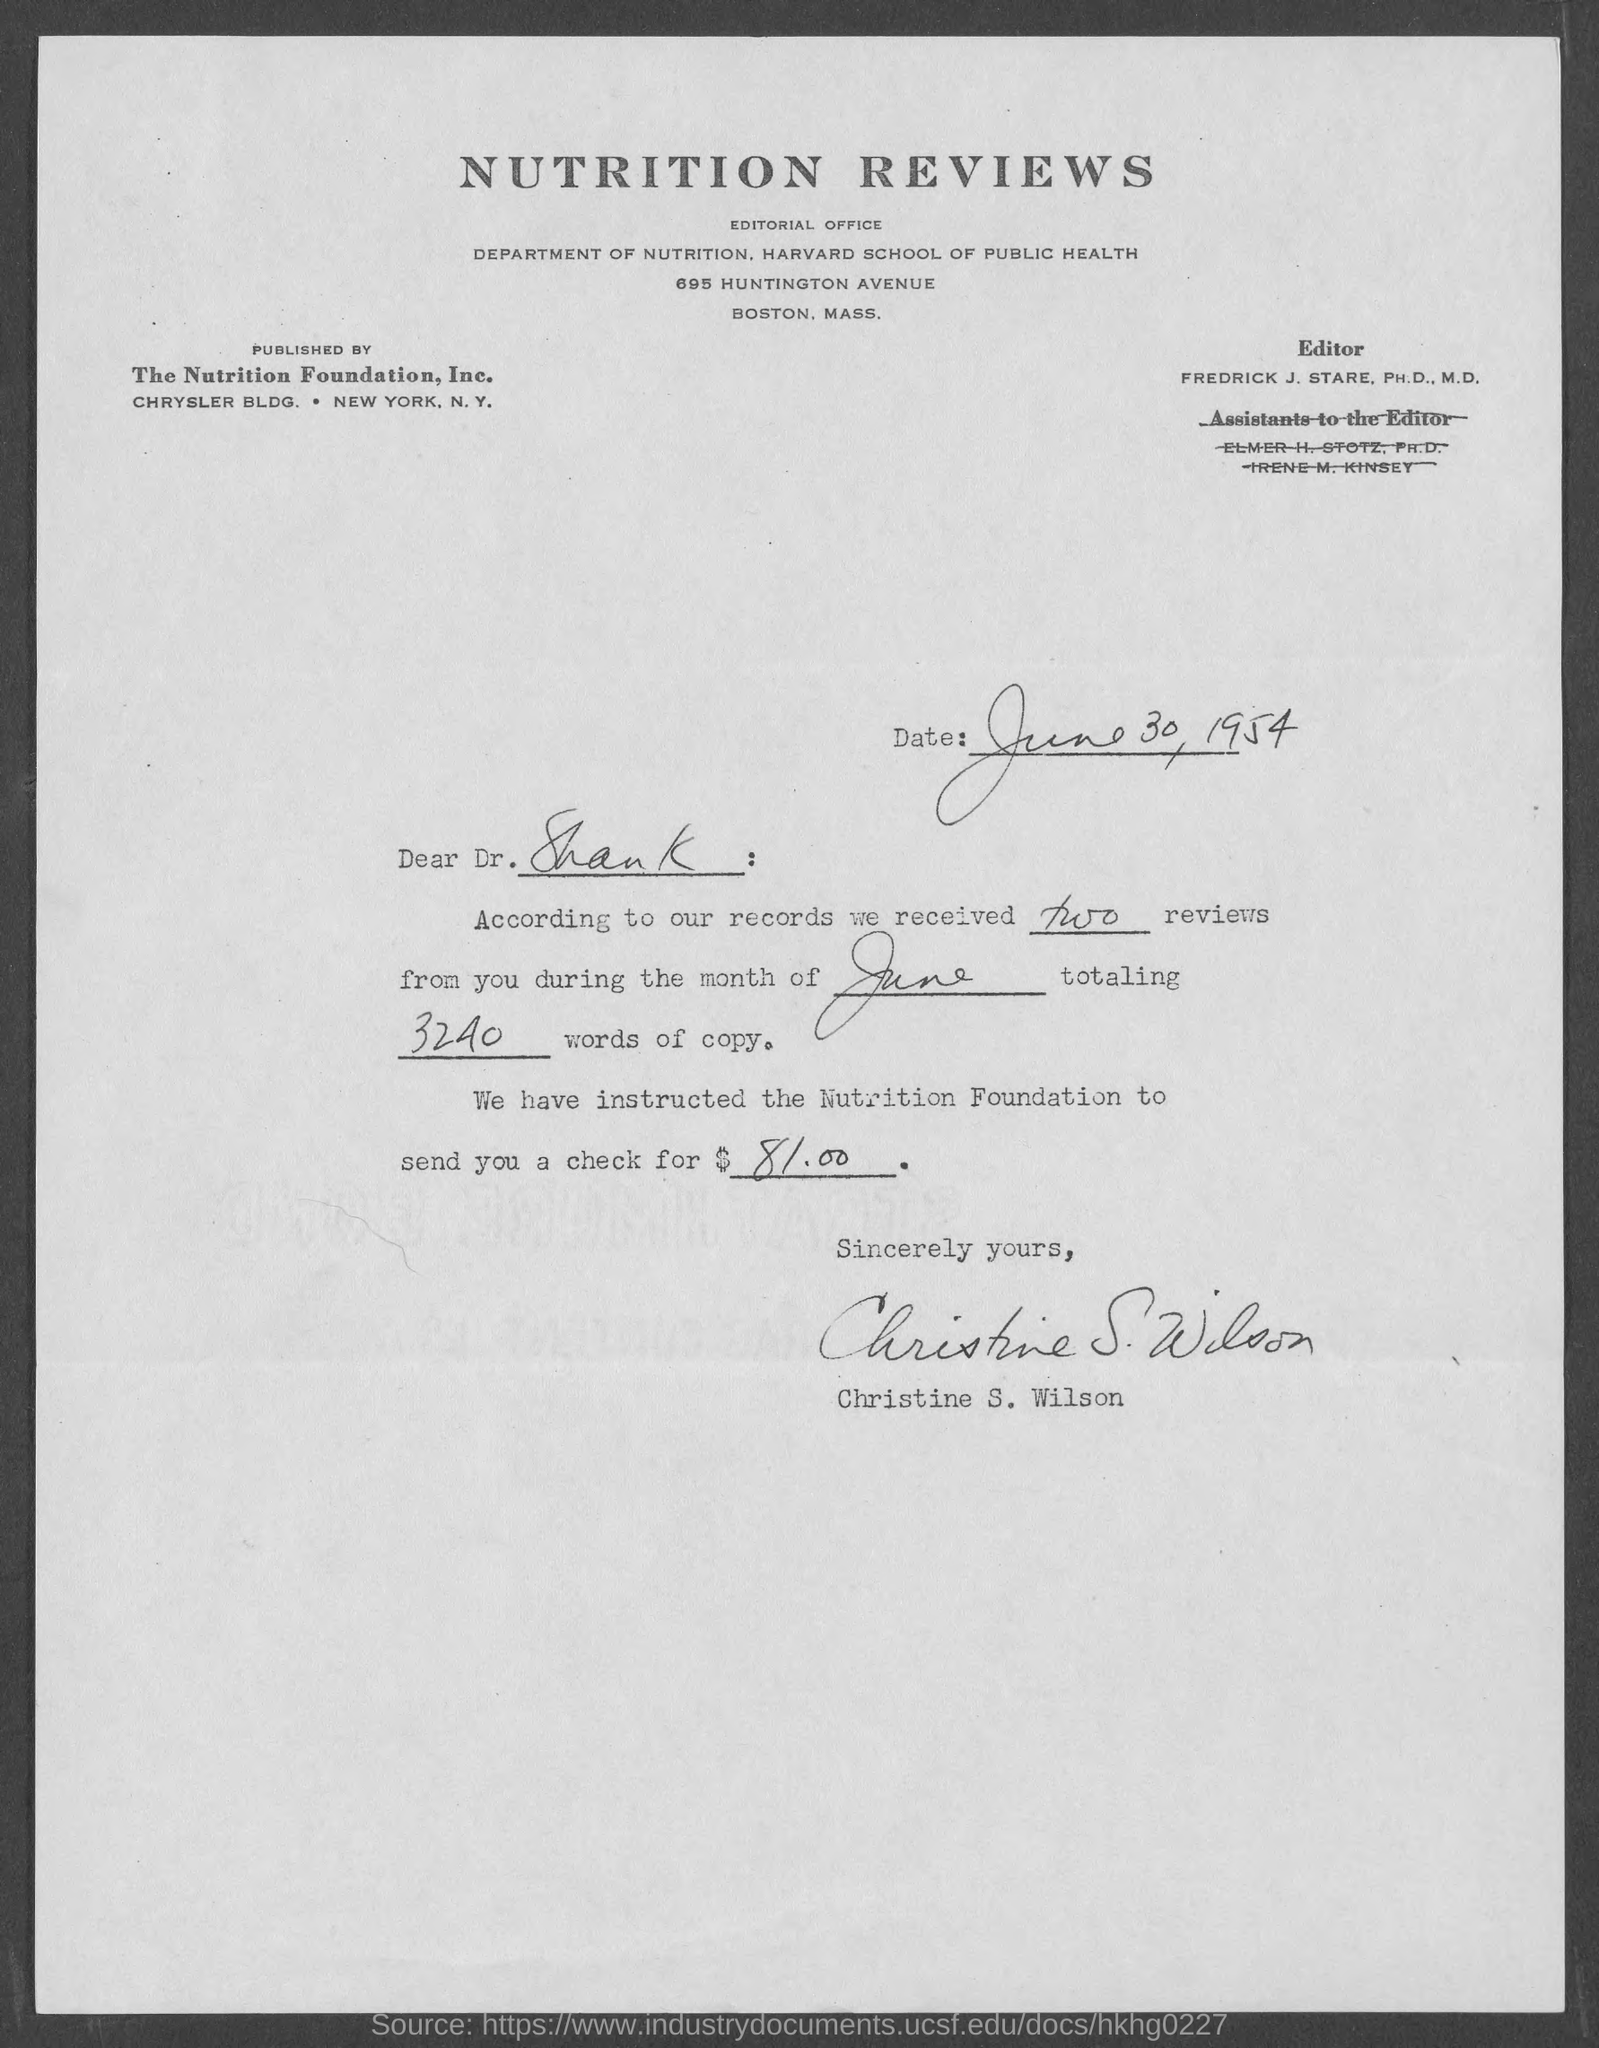What is the date mentioned in the given page ?
Your answer should be compact. June 30, 1954. To whom the letter was written ?
Make the answer very short. Dr. Shank. According to our records how many reviews were received ?
Ensure brevity in your answer.  Two. Total how many words of copy are mentioned in the given letetr ?
Make the answer very short. 3240. During which month the reviews were received as mentioned in the given letter ?
Offer a terse response. June. Who's sign was there at the end of the letter ?
Offer a terse response. Christine S. Wilson. What is the name of the editor mentioned in the given page ?
Give a very brief answer. Fredrick J. Stare. How much amount of check was instructed to the nutrition foundation ?
Offer a very short reply. $81.00. What is the department mentioned in the given page ?
Your response must be concise. DEPARTMENT OF NUTRITION. 